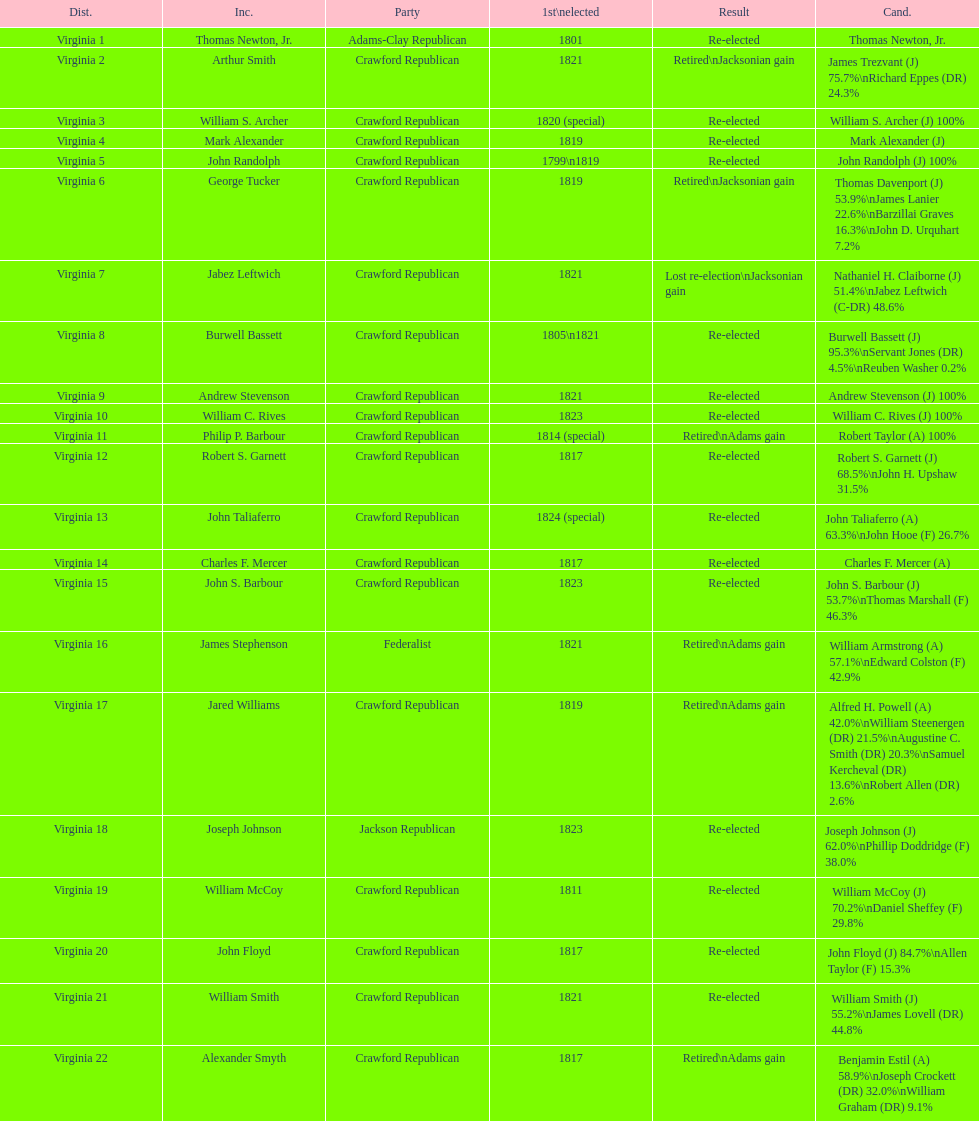Tell me the number of people first elected in 1817. 4. 